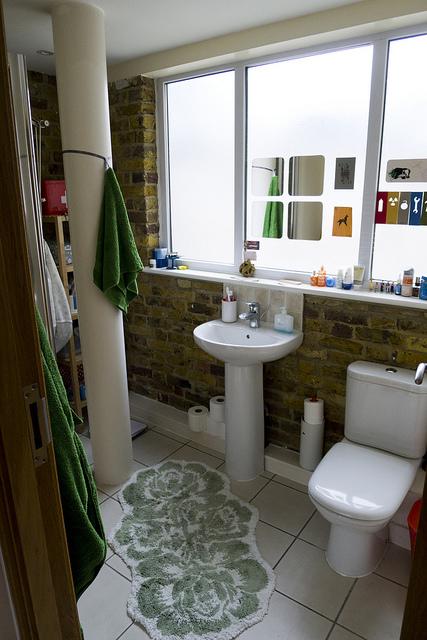What color is the toilet?
Be succinct. White. Are the windows open or closed?
Give a very brief answer. Closed. Is this a bathroom?
Keep it brief. Yes. How many vases are on the window sill?
Give a very brief answer. 0. What type of room is this?
Keep it brief. Bathroom. 